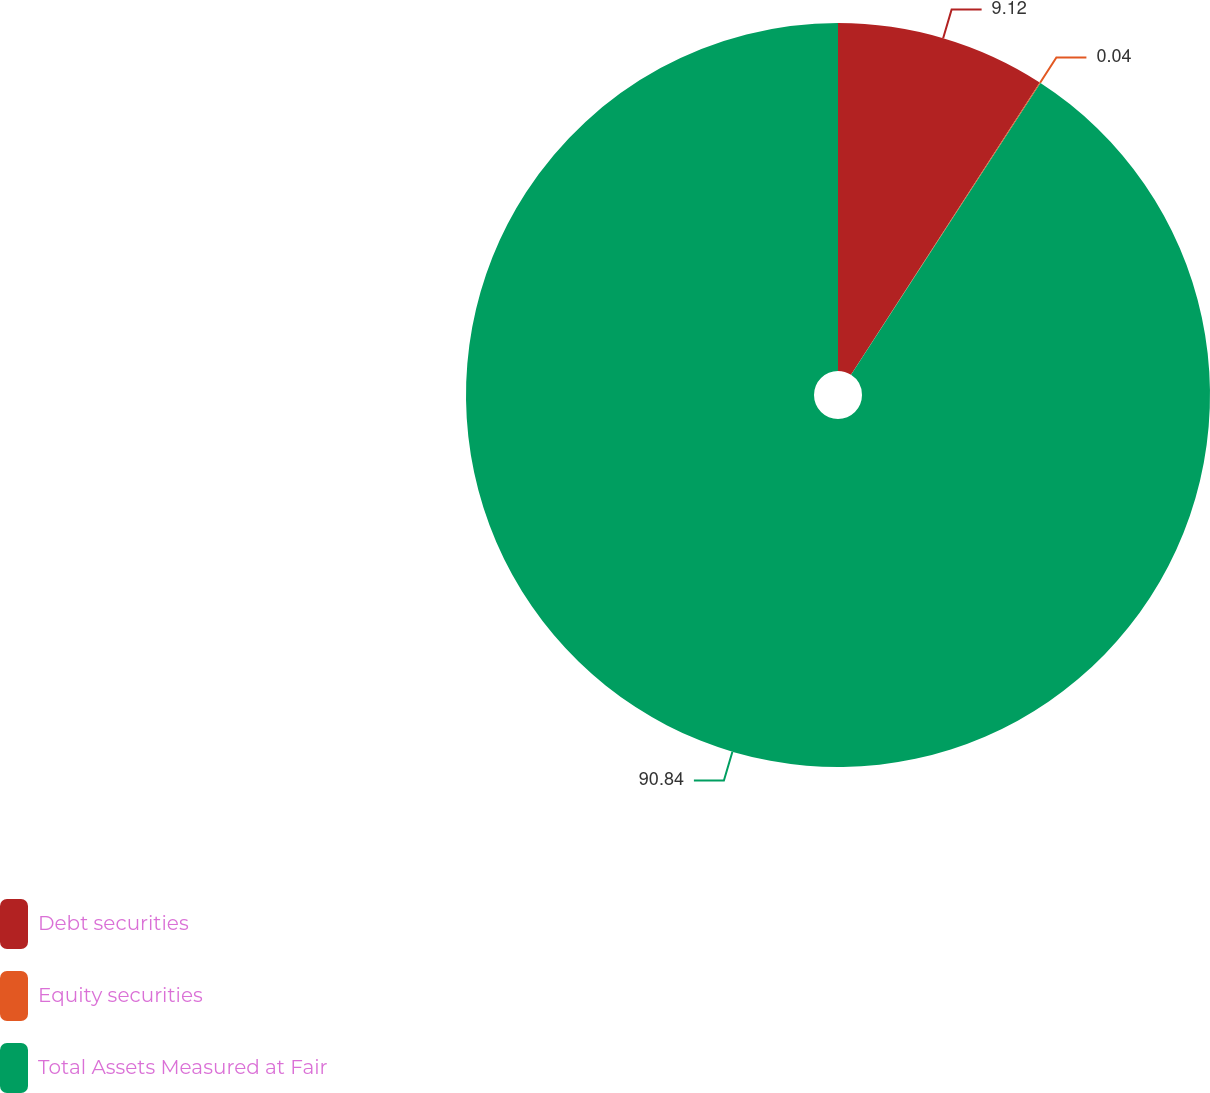Convert chart. <chart><loc_0><loc_0><loc_500><loc_500><pie_chart><fcel>Debt securities<fcel>Equity securities<fcel>Total Assets Measured at Fair<nl><fcel>9.12%<fcel>0.04%<fcel>90.83%<nl></chart> 